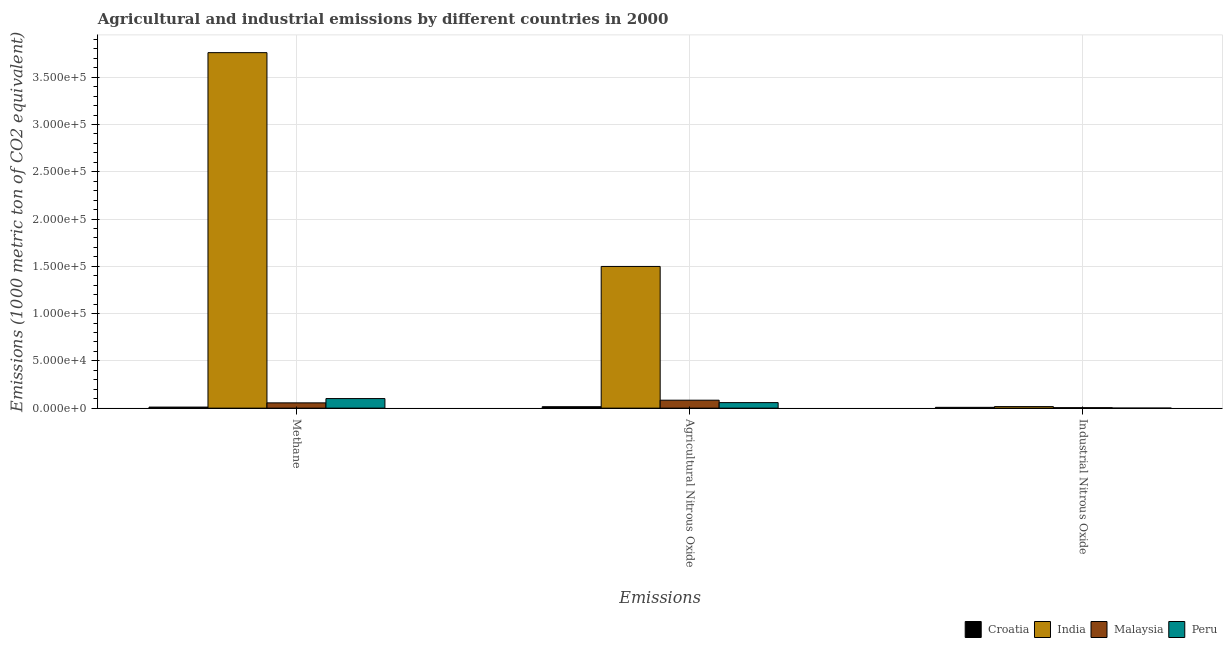How many different coloured bars are there?
Your response must be concise. 4. How many groups of bars are there?
Your answer should be compact. 3. Are the number of bars on each tick of the X-axis equal?
Make the answer very short. Yes. What is the label of the 2nd group of bars from the left?
Provide a short and direct response. Agricultural Nitrous Oxide. What is the amount of industrial nitrous oxide emissions in Croatia?
Provide a succinct answer. 854.3. Across all countries, what is the maximum amount of methane emissions?
Keep it short and to the point. 3.76e+05. Across all countries, what is the minimum amount of methane emissions?
Provide a short and direct response. 1124.5. In which country was the amount of methane emissions maximum?
Provide a short and direct response. India. In which country was the amount of methane emissions minimum?
Your answer should be compact. Croatia. What is the total amount of industrial nitrous oxide emissions in the graph?
Offer a terse response. 3024.9. What is the difference between the amount of methane emissions in Malaysia and that in Croatia?
Keep it short and to the point. 4454.7. What is the difference between the amount of industrial nitrous oxide emissions in India and the amount of methane emissions in Malaysia?
Give a very brief answer. -3935.9. What is the average amount of agricultural nitrous oxide emissions per country?
Make the answer very short. 4.14e+04. What is the difference between the amount of methane emissions and amount of industrial nitrous oxide emissions in Croatia?
Offer a terse response. 270.2. In how many countries, is the amount of industrial nitrous oxide emissions greater than 200000 metric ton?
Keep it short and to the point. 0. What is the ratio of the amount of agricultural nitrous oxide emissions in Malaysia to that in India?
Give a very brief answer. 0.06. What is the difference between the highest and the second highest amount of industrial nitrous oxide emissions?
Your response must be concise. 789. What is the difference between the highest and the lowest amount of methane emissions?
Provide a succinct answer. 3.75e+05. Is the sum of the amount of agricultural nitrous oxide emissions in India and Malaysia greater than the maximum amount of industrial nitrous oxide emissions across all countries?
Your response must be concise. Yes. What does the 3rd bar from the left in Agricultural Nitrous Oxide represents?
Offer a very short reply. Malaysia. What does the 3rd bar from the right in Industrial Nitrous Oxide represents?
Ensure brevity in your answer.  India. How many bars are there?
Offer a very short reply. 12. How many countries are there in the graph?
Keep it short and to the point. 4. What is the difference between two consecutive major ticks on the Y-axis?
Give a very brief answer. 5.00e+04. Does the graph contain any zero values?
Ensure brevity in your answer.  No. Does the graph contain grids?
Offer a very short reply. Yes. What is the title of the graph?
Your response must be concise. Agricultural and industrial emissions by different countries in 2000. What is the label or title of the X-axis?
Offer a terse response. Emissions. What is the label or title of the Y-axis?
Ensure brevity in your answer.  Emissions (1000 metric ton of CO2 equivalent). What is the Emissions (1000 metric ton of CO2 equivalent) of Croatia in Methane?
Provide a short and direct response. 1124.5. What is the Emissions (1000 metric ton of CO2 equivalent) in India in Methane?
Provide a short and direct response. 3.76e+05. What is the Emissions (1000 metric ton of CO2 equivalent) in Malaysia in Methane?
Your answer should be very brief. 5579.2. What is the Emissions (1000 metric ton of CO2 equivalent) of Peru in Methane?
Your answer should be very brief. 1.01e+04. What is the Emissions (1000 metric ton of CO2 equivalent) in Croatia in Agricultural Nitrous Oxide?
Offer a very short reply. 1522.5. What is the Emissions (1000 metric ton of CO2 equivalent) in India in Agricultural Nitrous Oxide?
Offer a terse response. 1.50e+05. What is the Emissions (1000 metric ton of CO2 equivalent) in Malaysia in Agricultural Nitrous Oxide?
Provide a short and direct response. 8403.2. What is the Emissions (1000 metric ton of CO2 equivalent) of Peru in Agricultural Nitrous Oxide?
Give a very brief answer. 5854.9. What is the Emissions (1000 metric ton of CO2 equivalent) in Croatia in Industrial Nitrous Oxide?
Your answer should be compact. 854.3. What is the Emissions (1000 metric ton of CO2 equivalent) in India in Industrial Nitrous Oxide?
Make the answer very short. 1643.3. What is the Emissions (1000 metric ton of CO2 equivalent) of Malaysia in Industrial Nitrous Oxide?
Provide a short and direct response. 493.8. What is the Emissions (1000 metric ton of CO2 equivalent) of Peru in Industrial Nitrous Oxide?
Make the answer very short. 33.5. Across all Emissions, what is the maximum Emissions (1000 metric ton of CO2 equivalent) in Croatia?
Your response must be concise. 1522.5. Across all Emissions, what is the maximum Emissions (1000 metric ton of CO2 equivalent) of India?
Ensure brevity in your answer.  3.76e+05. Across all Emissions, what is the maximum Emissions (1000 metric ton of CO2 equivalent) of Malaysia?
Your response must be concise. 8403.2. Across all Emissions, what is the maximum Emissions (1000 metric ton of CO2 equivalent) in Peru?
Ensure brevity in your answer.  1.01e+04. Across all Emissions, what is the minimum Emissions (1000 metric ton of CO2 equivalent) of Croatia?
Offer a terse response. 854.3. Across all Emissions, what is the minimum Emissions (1000 metric ton of CO2 equivalent) in India?
Keep it short and to the point. 1643.3. Across all Emissions, what is the minimum Emissions (1000 metric ton of CO2 equivalent) of Malaysia?
Offer a very short reply. 493.8. Across all Emissions, what is the minimum Emissions (1000 metric ton of CO2 equivalent) in Peru?
Ensure brevity in your answer.  33.5. What is the total Emissions (1000 metric ton of CO2 equivalent) in Croatia in the graph?
Your response must be concise. 3501.3. What is the total Emissions (1000 metric ton of CO2 equivalent) in India in the graph?
Give a very brief answer. 5.27e+05. What is the total Emissions (1000 metric ton of CO2 equivalent) in Malaysia in the graph?
Your answer should be very brief. 1.45e+04. What is the total Emissions (1000 metric ton of CO2 equivalent) in Peru in the graph?
Your response must be concise. 1.60e+04. What is the difference between the Emissions (1000 metric ton of CO2 equivalent) in Croatia in Methane and that in Agricultural Nitrous Oxide?
Provide a short and direct response. -398. What is the difference between the Emissions (1000 metric ton of CO2 equivalent) of India in Methane and that in Agricultural Nitrous Oxide?
Ensure brevity in your answer.  2.26e+05. What is the difference between the Emissions (1000 metric ton of CO2 equivalent) in Malaysia in Methane and that in Agricultural Nitrous Oxide?
Provide a short and direct response. -2824. What is the difference between the Emissions (1000 metric ton of CO2 equivalent) in Peru in Methane and that in Agricultural Nitrous Oxide?
Your answer should be compact. 4267. What is the difference between the Emissions (1000 metric ton of CO2 equivalent) of Croatia in Methane and that in Industrial Nitrous Oxide?
Offer a very short reply. 270.2. What is the difference between the Emissions (1000 metric ton of CO2 equivalent) in India in Methane and that in Industrial Nitrous Oxide?
Your answer should be compact. 3.74e+05. What is the difference between the Emissions (1000 metric ton of CO2 equivalent) of Malaysia in Methane and that in Industrial Nitrous Oxide?
Provide a short and direct response. 5085.4. What is the difference between the Emissions (1000 metric ton of CO2 equivalent) of Peru in Methane and that in Industrial Nitrous Oxide?
Provide a succinct answer. 1.01e+04. What is the difference between the Emissions (1000 metric ton of CO2 equivalent) of Croatia in Agricultural Nitrous Oxide and that in Industrial Nitrous Oxide?
Provide a succinct answer. 668.2. What is the difference between the Emissions (1000 metric ton of CO2 equivalent) of India in Agricultural Nitrous Oxide and that in Industrial Nitrous Oxide?
Provide a short and direct response. 1.48e+05. What is the difference between the Emissions (1000 metric ton of CO2 equivalent) in Malaysia in Agricultural Nitrous Oxide and that in Industrial Nitrous Oxide?
Ensure brevity in your answer.  7909.4. What is the difference between the Emissions (1000 metric ton of CO2 equivalent) of Peru in Agricultural Nitrous Oxide and that in Industrial Nitrous Oxide?
Ensure brevity in your answer.  5821.4. What is the difference between the Emissions (1000 metric ton of CO2 equivalent) in Croatia in Methane and the Emissions (1000 metric ton of CO2 equivalent) in India in Agricultural Nitrous Oxide?
Offer a very short reply. -1.49e+05. What is the difference between the Emissions (1000 metric ton of CO2 equivalent) in Croatia in Methane and the Emissions (1000 metric ton of CO2 equivalent) in Malaysia in Agricultural Nitrous Oxide?
Your answer should be compact. -7278.7. What is the difference between the Emissions (1000 metric ton of CO2 equivalent) of Croatia in Methane and the Emissions (1000 metric ton of CO2 equivalent) of Peru in Agricultural Nitrous Oxide?
Make the answer very short. -4730.4. What is the difference between the Emissions (1000 metric ton of CO2 equivalent) of India in Methane and the Emissions (1000 metric ton of CO2 equivalent) of Malaysia in Agricultural Nitrous Oxide?
Give a very brief answer. 3.68e+05. What is the difference between the Emissions (1000 metric ton of CO2 equivalent) of India in Methane and the Emissions (1000 metric ton of CO2 equivalent) of Peru in Agricultural Nitrous Oxide?
Keep it short and to the point. 3.70e+05. What is the difference between the Emissions (1000 metric ton of CO2 equivalent) in Malaysia in Methane and the Emissions (1000 metric ton of CO2 equivalent) in Peru in Agricultural Nitrous Oxide?
Provide a short and direct response. -275.7. What is the difference between the Emissions (1000 metric ton of CO2 equivalent) in Croatia in Methane and the Emissions (1000 metric ton of CO2 equivalent) in India in Industrial Nitrous Oxide?
Your answer should be compact. -518.8. What is the difference between the Emissions (1000 metric ton of CO2 equivalent) in Croatia in Methane and the Emissions (1000 metric ton of CO2 equivalent) in Malaysia in Industrial Nitrous Oxide?
Provide a short and direct response. 630.7. What is the difference between the Emissions (1000 metric ton of CO2 equivalent) of Croatia in Methane and the Emissions (1000 metric ton of CO2 equivalent) of Peru in Industrial Nitrous Oxide?
Keep it short and to the point. 1091. What is the difference between the Emissions (1000 metric ton of CO2 equivalent) in India in Methane and the Emissions (1000 metric ton of CO2 equivalent) in Malaysia in Industrial Nitrous Oxide?
Keep it short and to the point. 3.75e+05. What is the difference between the Emissions (1000 metric ton of CO2 equivalent) in India in Methane and the Emissions (1000 metric ton of CO2 equivalent) in Peru in Industrial Nitrous Oxide?
Offer a terse response. 3.76e+05. What is the difference between the Emissions (1000 metric ton of CO2 equivalent) in Malaysia in Methane and the Emissions (1000 metric ton of CO2 equivalent) in Peru in Industrial Nitrous Oxide?
Provide a succinct answer. 5545.7. What is the difference between the Emissions (1000 metric ton of CO2 equivalent) in Croatia in Agricultural Nitrous Oxide and the Emissions (1000 metric ton of CO2 equivalent) in India in Industrial Nitrous Oxide?
Provide a short and direct response. -120.8. What is the difference between the Emissions (1000 metric ton of CO2 equivalent) of Croatia in Agricultural Nitrous Oxide and the Emissions (1000 metric ton of CO2 equivalent) of Malaysia in Industrial Nitrous Oxide?
Make the answer very short. 1028.7. What is the difference between the Emissions (1000 metric ton of CO2 equivalent) of Croatia in Agricultural Nitrous Oxide and the Emissions (1000 metric ton of CO2 equivalent) of Peru in Industrial Nitrous Oxide?
Offer a very short reply. 1489. What is the difference between the Emissions (1000 metric ton of CO2 equivalent) in India in Agricultural Nitrous Oxide and the Emissions (1000 metric ton of CO2 equivalent) in Malaysia in Industrial Nitrous Oxide?
Your answer should be compact. 1.49e+05. What is the difference between the Emissions (1000 metric ton of CO2 equivalent) of India in Agricultural Nitrous Oxide and the Emissions (1000 metric ton of CO2 equivalent) of Peru in Industrial Nitrous Oxide?
Provide a succinct answer. 1.50e+05. What is the difference between the Emissions (1000 metric ton of CO2 equivalent) of Malaysia in Agricultural Nitrous Oxide and the Emissions (1000 metric ton of CO2 equivalent) of Peru in Industrial Nitrous Oxide?
Offer a terse response. 8369.7. What is the average Emissions (1000 metric ton of CO2 equivalent) of Croatia per Emissions?
Offer a very short reply. 1167.1. What is the average Emissions (1000 metric ton of CO2 equivalent) in India per Emissions?
Your answer should be very brief. 1.76e+05. What is the average Emissions (1000 metric ton of CO2 equivalent) of Malaysia per Emissions?
Keep it short and to the point. 4825.4. What is the average Emissions (1000 metric ton of CO2 equivalent) in Peru per Emissions?
Offer a very short reply. 5336.77. What is the difference between the Emissions (1000 metric ton of CO2 equivalent) in Croatia and Emissions (1000 metric ton of CO2 equivalent) in India in Methane?
Offer a terse response. -3.75e+05. What is the difference between the Emissions (1000 metric ton of CO2 equivalent) of Croatia and Emissions (1000 metric ton of CO2 equivalent) of Malaysia in Methane?
Offer a very short reply. -4454.7. What is the difference between the Emissions (1000 metric ton of CO2 equivalent) in Croatia and Emissions (1000 metric ton of CO2 equivalent) in Peru in Methane?
Make the answer very short. -8997.4. What is the difference between the Emissions (1000 metric ton of CO2 equivalent) of India and Emissions (1000 metric ton of CO2 equivalent) of Malaysia in Methane?
Offer a very short reply. 3.70e+05. What is the difference between the Emissions (1000 metric ton of CO2 equivalent) in India and Emissions (1000 metric ton of CO2 equivalent) in Peru in Methane?
Make the answer very short. 3.66e+05. What is the difference between the Emissions (1000 metric ton of CO2 equivalent) of Malaysia and Emissions (1000 metric ton of CO2 equivalent) of Peru in Methane?
Make the answer very short. -4542.7. What is the difference between the Emissions (1000 metric ton of CO2 equivalent) in Croatia and Emissions (1000 metric ton of CO2 equivalent) in India in Agricultural Nitrous Oxide?
Keep it short and to the point. -1.48e+05. What is the difference between the Emissions (1000 metric ton of CO2 equivalent) in Croatia and Emissions (1000 metric ton of CO2 equivalent) in Malaysia in Agricultural Nitrous Oxide?
Provide a short and direct response. -6880.7. What is the difference between the Emissions (1000 metric ton of CO2 equivalent) in Croatia and Emissions (1000 metric ton of CO2 equivalent) in Peru in Agricultural Nitrous Oxide?
Give a very brief answer. -4332.4. What is the difference between the Emissions (1000 metric ton of CO2 equivalent) in India and Emissions (1000 metric ton of CO2 equivalent) in Malaysia in Agricultural Nitrous Oxide?
Give a very brief answer. 1.41e+05. What is the difference between the Emissions (1000 metric ton of CO2 equivalent) of India and Emissions (1000 metric ton of CO2 equivalent) of Peru in Agricultural Nitrous Oxide?
Keep it short and to the point. 1.44e+05. What is the difference between the Emissions (1000 metric ton of CO2 equivalent) in Malaysia and Emissions (1000 metric ton of CO2 equivalent) in Peru in Agricultural Nitrous Oxide?
Provide a succinct answer. 2548.3. What is the difference between the Emissions (1000 metric ton of CO2 equivalent) in Croatia and Emissions (1000 metric ton of CO2 equivalent) in India in Industrial Nitrous Oxide?
Give a very brief answer. -789. What is the difference between the Emissions (1000 metric ton of CO2 equivalent) of Croatia and Emissions (1000 metric ton of CO2 equivalent) of Malaysia in Industrial Nitrous Oxide?
Keep it short and to the point. 360.5. What is the difference between the Emissions (1000 metric ton of CO2 equivalent) of Croatia and Emissions (1000 metric ton of CO2 equivalent) of Peru in Industrial Nitrous Oxide?
Your answer should be compact. 820.8. What is the difference between the Emissions (1000 metric ton of CO2 equivalent) of India and Emissions (1000 metric ton of CO2 equivalent) of Malaysia in Industrial Nitrous Oxide?
Your answer should be compact. 1149.5. What is the difference between the Emissions (1000 metric ton of CO2 equivalent) of India and Emissions (1000 metric ton of CO2 equivalent) of Peru in Industrial Nitrous Oxide?
Provide a short and direct response. 1609.8. What is the difference between the Emissions (1000 metric ton of CO2 equivalent) of Malaysia and Emissions (1000 metric ton of CO2 equivalent) of Peru in Industrial Nitrous Oxide?
Ensure brevity in your answer.  460.3. What is the ratio of the Emissions (1000 metric ton of CO2 equivalent) in Croatia in Methane to that in Agricultural Nitrous Oxide?
Your response must be concise. 0.74. What is the ratio of the Emissions (1000 metric ton of CO2 equivalent) of India in Methane to that in Agricultural Nitrous Oxide?
Ensure brevity in your answer.  2.51. What is the ratio of the Emissions (1000 metric ton of CO2 equivalent) of Malaysia in Methane to that in Agricultural Nitrous Oxide?
Your answer should be compact. 0.66. What is the ratio of the Emissions (1000 metric ton of CO2 equivalent) of Peru in Methane to that in Agricultural Nitrous Oxide?
Your answer should be very brief. 1.73. What is the ratio of the Emissions (1000 metric ton of CO2 equivalent) in Croatia in Methane to that in Industrial Nitrous Oxide?
Provide a short and direct response. 1.32. What is the ratio of the Emissions (1000 metric ton of CO2 equivalent) in India in Methane to that in Industrial Nitrous Oxide?
Offer a very short reply. 228.79. What is the ratio of the Emissions (1000 metric ton of CO2 equivalent) of Malaysia in Methane to that in Industrial Nitrous Oxide?
Your answer should be very brief. 11.3. What is the ratio of the Emissions (1000 metric ton of CO2 equivalent) in Peru in Methane to that in Industrial Nitrous Oxide?
Provide a short and direct response. 302.15. What is the ratio of the Emissions (1000 metric ton of CO2 equivalent) of Croatia in Agricultural Nitrous Oxide to that in Industrial Nitrous Oxide?
Provide a succinct answer. 1.78. What is the ratio of the Emissions (1000 metric ton of CO2 equivalent) of India in Agricultural Nitrous Oxide to that in Industrial Nitrous Oxide?
Your response must be concise. 91.2. What is the ratio of the Emissions (1000 metric ton of CO2 equivalent) in Malaysia in Agricultural Nitrous Oxide to that in Industrial Nitrous Oxide?
Keep it short and to the point. 17.02. What is the ratio of the Emissions (1000 metric ton of CO2 equivalent) in Peru in Agricultural Nitrous Oxide to that in Industrial Nitrous Oxide?
Offer a very short reply. 174.77. What is the difference between the highest and the second highest Emissions (1000 metric ton of CO2 equivalent) of Croatia?
Offer a very short reply. 398. What is the difference between the highest and the second highest Emissions (1000 metric ton of CO2 equivalent) of India?
Your answer should be compact. 2.26e+05. What is the difference between the highest and the second highest Emissions (1000 metric ton of CO2 equivalent) in Malaysia?
Your response must be concise. 2824. What is the difference between the highest and the second highest Emissions (1000 metric ton of CO2 equivalent) in Peru?
Your response must be concise. 4267. What is the difference between the highest and the lowest Emissions (1000 metric ton of CO2 equivalent) in Croatia?
Offer a very short reply. 668.2. What is the difference between the highest and the lowest Emissions (1000 metric ton of CO2 equivalent) in India?
Your answer should be very brief. 3.74e+05. What is the difference between the highest and the lowest Emissions (1000 metric ton of CO2 equivalent) of Malaysia?
Your answer should be very brief. 7909.4. What is the difference between the highest and the lowest Emissions (1000 metric ton of CO2 equivalent) of Peru?
Offer a terse response. 1.01e+04. 